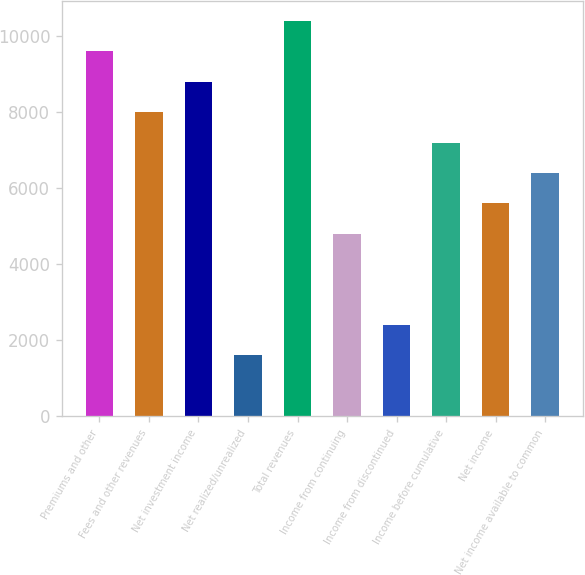<chart> <loc_0><loc_0><loc_500><loc_500><bar_chart><fcel>Premiums and other<fcel>Fees and other revenues<fcel>Net investment income<fcel>Net realized/unrealized<fcel>Total revenues<fcel>Income from continuing<fcel>Income from discontinued<fcel>Income before cumulative<fcel>Net income<fcel>Net income available to common<nl><fcel>9590.09<fcel>7992.07<fcel>8791.08<fcel>1599.99<fcel>10389.1<fcel>4796.03<fcel>2399<fcel>7193.06<fcel>5595.04<fcel>6394.05<nl></chart> 